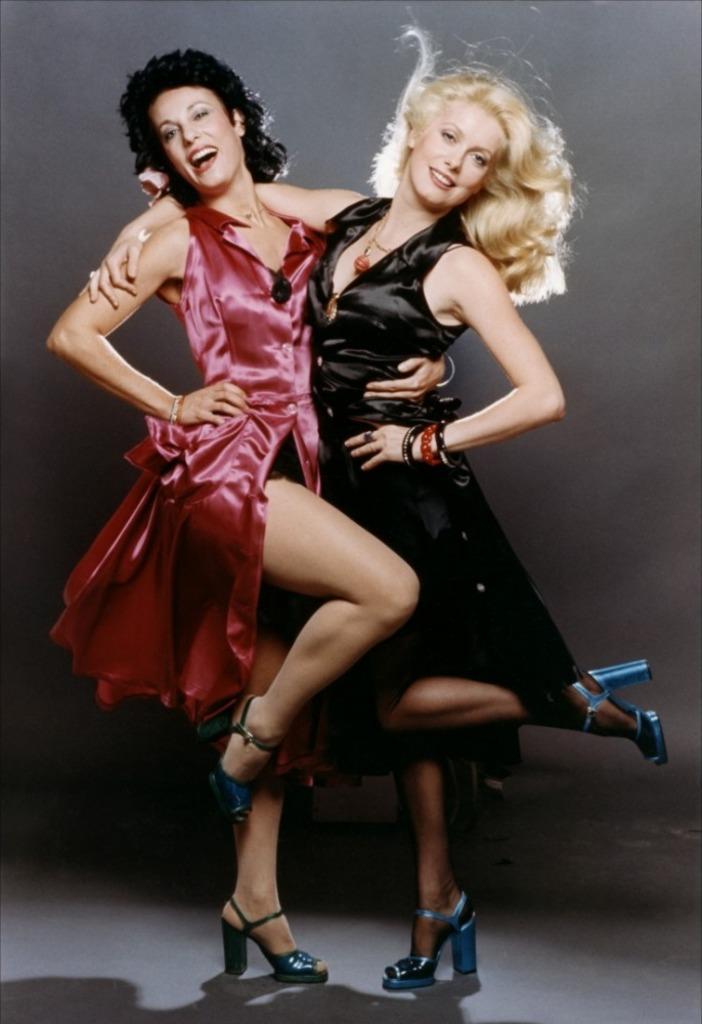Describe this image in one or two sentences. This picture shows a couple of women holding each other with their hands and we see smile on their faces and we see a woman wore a black dress and another woman wore red dress. we see a black background. 